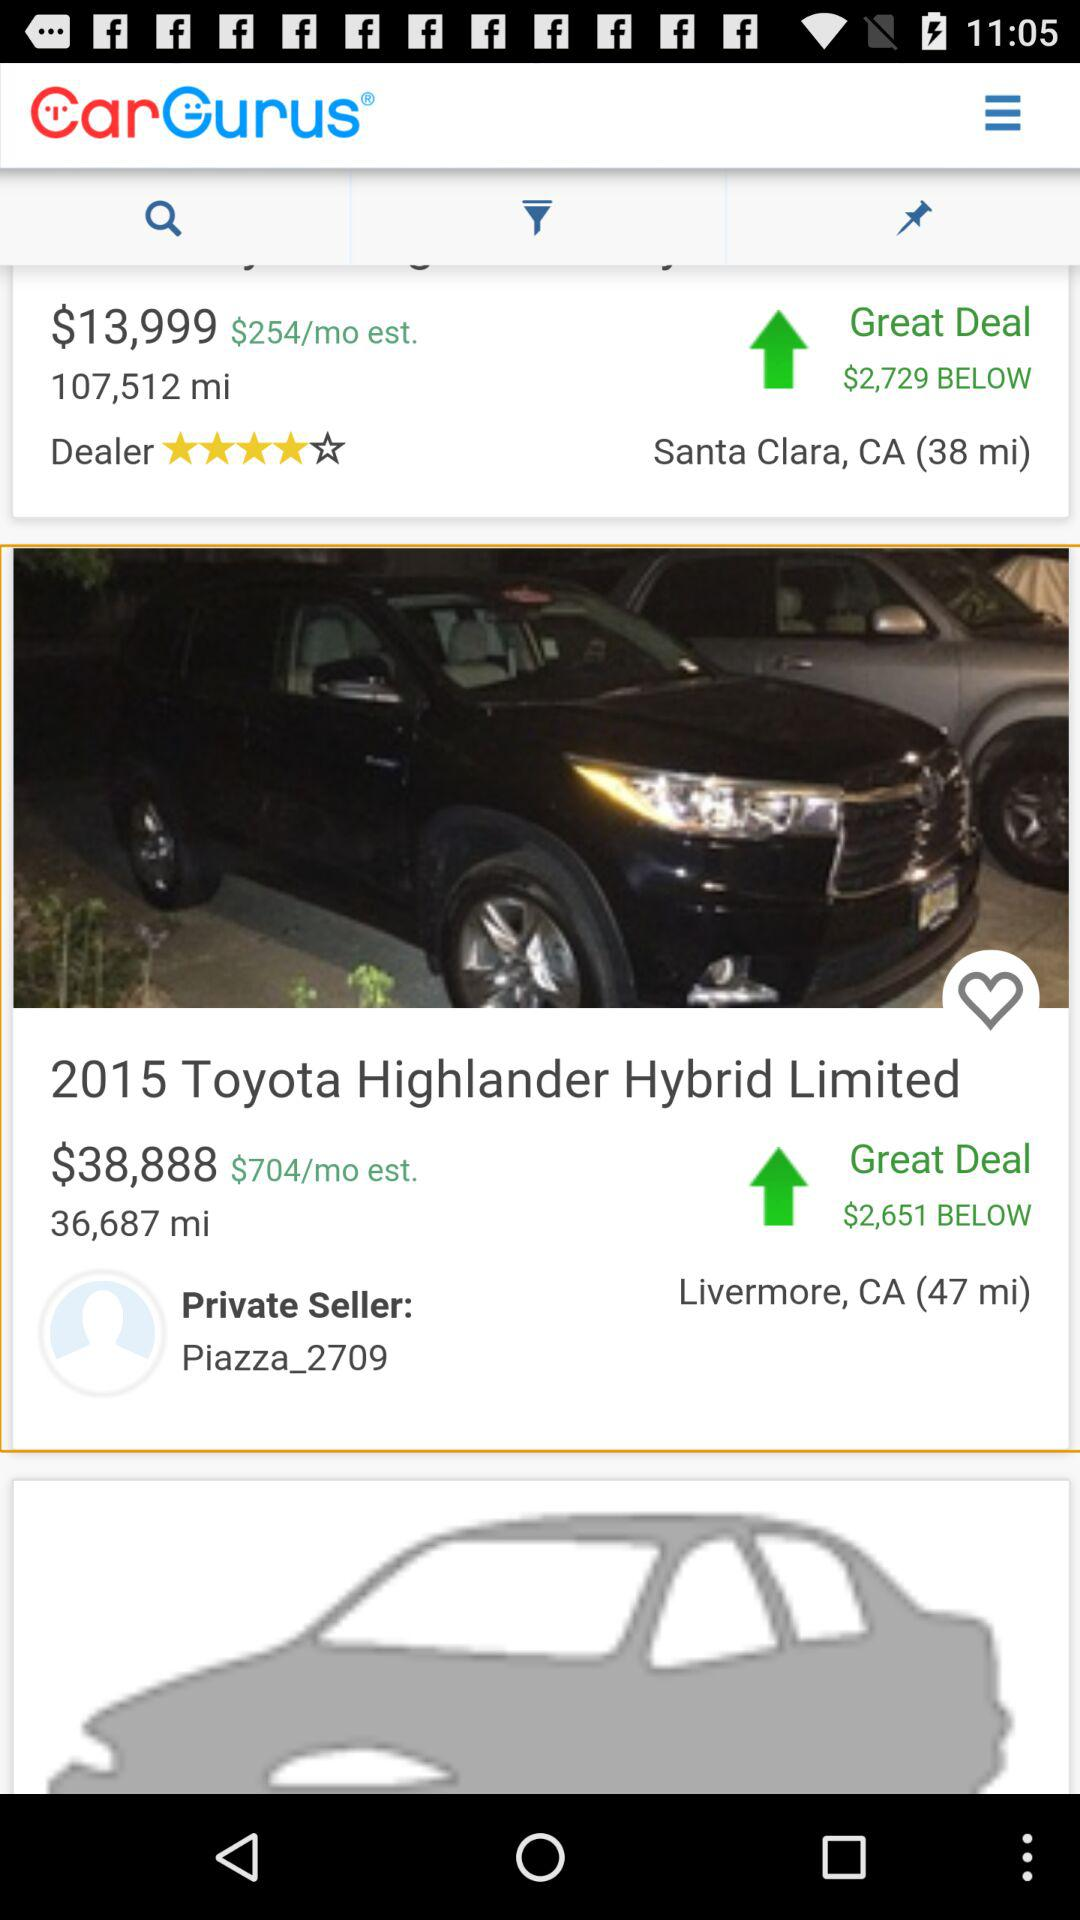What is the price of "2015 Toyota Highlander Hybrid Limited"? The price is $38,888. 